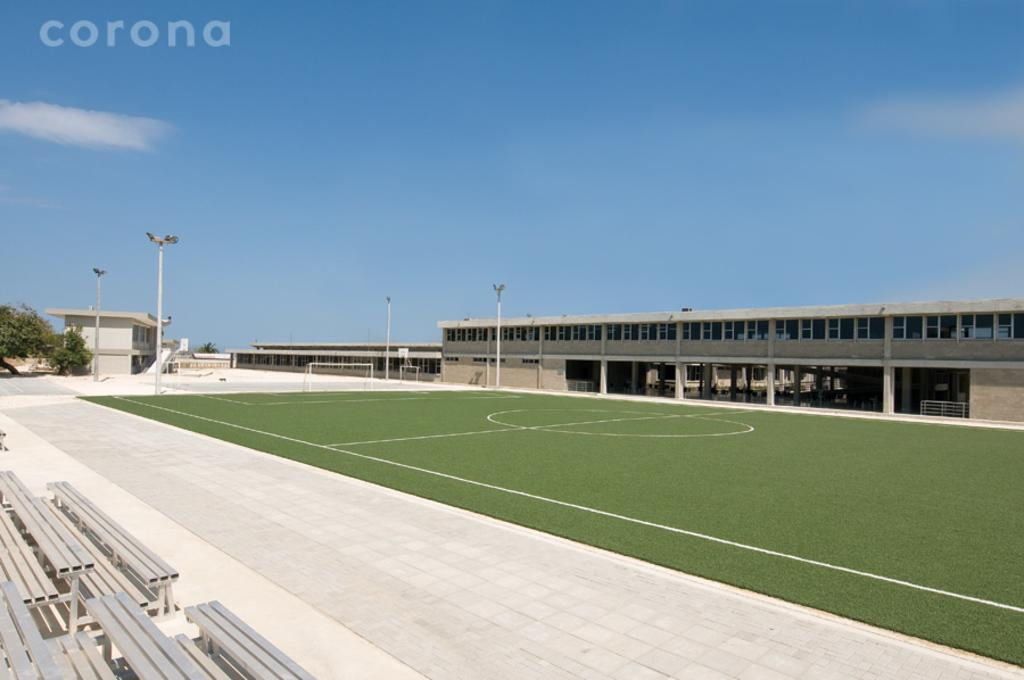What type of seating is available in the image? There are benches in the image. What can be seen illuminating the area in the image? There are lights in the image. What structures are supporting the lights in the image? There are poles in the image. What sports equipment is present in the image? There is a football net in the image. What type of sports facility is depicted in the image? There is a football court in the image. What type of large venue is shown in the image? There is a stadium in the image. What type of natural vegetation is present in the image? There are trees in the image. What part of the natural environment is visible in the background of the image? The sky is visible in the background of the image. How many legs are visible on the benches in the image? The benches in the image do not have legs; they are attached to the ground. What type of wood is used to construct the football net in the image? There is no wood present in the image; the football net is made of synthetic materials. 